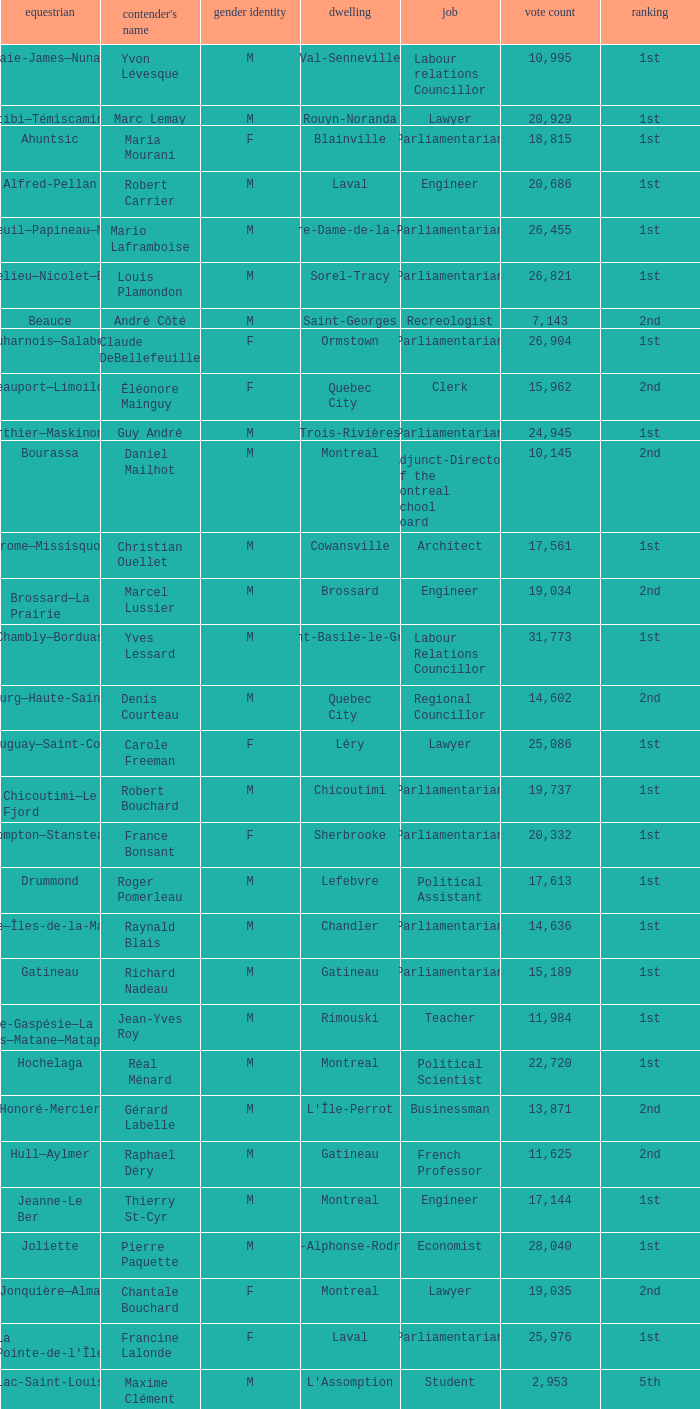Can you parse all the data within this table? {'header': ['equestrian', "contender's name", 'gender identity', 'dwelling', 'job', 'vote count', 'ranking'], 'rows': [['Abitibi—Baie-James—Nunavik—Eeyou', 'Yvon Lévesque', 'M', 'Val-Senneville', 'Labour relations Councillor', '10,995', '1st'], ['Abitibi—Témiscamingue', 'Marc Lemay', 'M', 'Rouyn-Noranda', 'Lawyer', '20,929', '1st'], ['Ahuntsic', 'Maria Mourani', 'F', 'Blainville', 'Parliamentarian', '18,815', '1st'], ['Alfred-Pellan', 'Robert Carrier', 'M', 'Laval', 'Engineer', '20,686', '1st'], ['Argenteuil—Papineau—Mirabel', 'Mario Laframboise', 'M', 'Notre-Dame-de-la-Paix', 'Parliamentarian', '26,455', '1st'], ['Bas-Richelieu—Nicolet—Bécancour', 'Louis Plamondon', 'M', 'Sorel-Tracy', 'Parliamentarian', '26,821', '1st'], ['Beauce', 'André Côté', 'M', 'Saint-Georges', 'Recreologist', '7,143', '2nd'], ['Beauharnois—Salaberry', 'Claude DeBellefeuille', 'F', 'Ormstown', 'Parliamentarian', '26,904', '1st'], ['Beauport—Limoilou', 'Éléonore Mainguy', 'F', 'Quebec City', 'Clerk', '15,962', '2nd'], ['Berthier—Maskinongé', 'Guy André', 'M', 'Trois-Rivières', 'Parliamentarian', '24,945', '1st'], ['Bourassa', 'Daniel Mailhot', 'M', 'Montreal', 'Adjunct-Director of the Montreal School Board', '10,145', '2nd'], ['Brome—Missisquoi', 'Christian Ouellet', 'M', 'Cowansville', 'Architect', '17,561', '1st'], ['Brossard—La Prairie', 'Marcel Lussier', 'M', 'Brossard', 'Engineer', '19,034', '2nd'], ['Chambly—Borduas', 'Yves Lessard', 'M', 'Saint-Basile-le-Grand', 'Labour Relations Councillor', '31,773', '1st'], ['Charlesbourg—Haute-Saint-Charles', 'Denis Courteau', 'M', 'Quebec City', 'Regional Councillor', '14,602', '2nd'], ['Châteauguay—Saint-Constant', 'Carole Freeman', 'F', 'Léry', 'Lawyer', '25,086', '1st'], ['Chicoutimi—Le Fjord', 'Robert Bouchard', 'M', 'Chicoutimi', 'Parliamentarian', '19,737', '1st'], ['Compton—Stanstead', 'France Bonsant', 'F', 'Sherbrooke', 'Parliamentarian', '20,332', '1st'], ['Drummond', 'Roger Pomerleau', 'M', 'Lefebvre', 'Political Assistant', '17,613', '1st'], ['Gaspésie—Îles-de-la-Madeleine', 'Raynald Blais', 'M', 'Chandler', 'Parliamentarian', '14,636', '1st'], ['Gatineau', 'Richard Nadeau', 'M', 'Gatineau', 'Parliamentarian', '15,189', '1st'], ['Haute-Gaspésie—La Mitis—Matane—Matapédia', 'Jean-Yves Roy', 'M', 'Rimouski', 'Teacher', '11,984', '1st'], ['Hochelaga', 'Réal Ménard', 'M', 'Montreal', 'Political Scientist', '22,720', '1st'], ['Honoré-Mercier', 'Gérard Labelle', 'M', "L'Île-Perrot", 'Businessman', '13,871', '2nd'], ['Hull—Aylmer', 'Raphael Déry', 'M', 'Gatineau', 'French Professor', '11,625', '2nd'], ['Jeanne-Le Ber', 'Thierry St-Cyr', 'M', 'Montreal', 'Engineer', '17,144', '1st'], ['Joliette', 'Pierre Paquette', 'M', 'Saint-Alphonse-Rodriguez', 'Economist', '28,040', '1st'], ['Jonquière—Alma', 'Chantale Bouchard', 'F', 'Montreal', 'Lawyer', '19,035', '2nd'], ["La Pointe-de-l'Île", 'Francine Lalonde', 'F', 'Laval', 'Parliamentarian', '25,976', '1st'], ['Lac-Saint-Louis', 'Maxime Clément', 'M', "L'Assomption", 'Student', '2,953', '5th'], ['LaSalle—Émard', 'Frédéric Isaya', 'M', 'Montreal', 'Actor', '10,384', '2nd'], ['Laurentides—Labelle', 'Johanne Deschamps', 'F', 'Mont-Laurier', 'Parliamentarian', '24,956', '1st'], ['Laurier—Sainte-Marie', 'Gilles Duceppe', 'M', 'Montreal', 'Parliamentarian', '24,103', '1st'], ['Laval', 'Nicole Demers', 'F', 'Laval', 'Parliamentarian', '19,085', '1st'], ['Laval—Les Îles', 'Mohamedali Jetha', 'M', 'Laval', 'Machinist', '12,576', '2nd'], ['Lévis—Bellechasse', 'Guy Bergeron', 'M', 'Quebec City', 'Political Scientist', '13,747', '2nd'], ['Longueuil—Pierre-Boucher', 'Jean Dorion', 'M', 'Montreal', 'Sociologist', '23,118', '1st'], ['Lotbinière—Chutes-de-la-Chaudière', 'Antoine Sarrazin-Bourgoin', 'M', 'Saint-Antoine-de-Tilly', 'Student', '12,738', '2nd'], ['Louis-Hébert', 'Pascal-Pierre Paillé', 'M', 'Quebec City', 'Teacher', '20,992', '1st'], ['Louis-Saint-Laurent', 'France Gagné', 'F', 'Quebec City', 'Technician', '13,330', '2nd'], ['Manicouagan', 'Gérard Asselin', 'M', 'Baie-Comeau', 'Parliamentarian', '15,272', '1st'], ['Marc-Aurèle-Fortin', 'Serge Ménard', 'M', 'Saint-Lambert', 'Lawyer', '25,552', '1st'], ["Mégantic—L'Érable", 'Pierre Turcotte', 'M', 'Thetford Mines', 'Notary', '12,283', '2nd'], ['Montcalm', 'Roger Gaudet', 'M', 'Saint-Liguori', 'Parliamentarian', '33,519', '1st'], ["Montmagny—L'Islet—Kamouraska—Rivière-du-Loup", 'Paul Crête', 'M', 'La Pocatière', 'Parliamentarian', '20,494', '1st'], ['Montmorency—Charlevoix—Haute-Côte-Nord', 'Michel Guimond', 'M', 'Boischatel', 'Parliamentarian and Lawyer', '21,068', '1st'], ['Mount Royal', 'Maryse Lavallée', 'F', 'Montreal', 'Director of Québec Alcohol Corporation', '1,543', '5th'], ['Notre-Dame-de-Grâce—Lachine', 'Eric Taillefer', 'M', 'Terrebonne', 'Student', '6,962', '3rd'], ['Outremont', 'Marcela Valdivia', 'F', 'Montreal', 'Lawyer', '4,554', '3rd'], ['Papineau', 'Vivian Barbot', 'F', 'Montreal', 'Parliamentarian', '16,535', '2nd'], ['Pierrefonds—Dollard', 'Reny Gagnon', 'M', 'Laval', 'Insurance Salesman', '4,357', '4th'], ['Pontiac', 'Marius Tremblay', 'M', 'Plaisance', 'Composer/Researcher', '9,576', '3rd'], ['Portneuf—Jacques-Cartier', 'Richard Côté', 'M', 'Neuville', 'Polling Director', '14,401', '2nd'], ['Québec', 'Christiane Gagnon', 'F', 'Quebec City', 'Real Estate Agent', '21,064', '1st'], ['Repentigny', 'Nicolas Dufour', 'M', 'Repentigny', 'Student', '31,007', '1st'], ['Richmond—Arthabaska', 'André Bellavance', 'M', 'Victoriaville', 'Parliamentarian', '23,913', '1st'], ['Rimouski-Neigette—Témiscouata—Les Basques', 'Claude Guimond', 'M', 'Rimouski', 'Farmer', '17,652', '1st'], ['Rivière-des-Mille-Îles', 'Luc Desnoyers', 'M', 'Montreal', 'Retired', '23,216', '1st'], ['Rivière-du-Nord', 'Monique Guay', 'F', 'Prévost', 'Parliamentarian', '26,588', '1st'], ['Roberval—Lac-Saint-Jean', 'Claude Pilote', 'M', 'Roberval', 'Businessman', '14,619', '2nd'], ['Rosemont—La Petite-Patrie', 'Bernard Bigras', 'M', 'Montreal', 'Parliamentarian', '27,260', '1st'], ['Saint-Bruno—Saint-Hubert', 'Carole Lavallée', 'F', 'Longueuil', 'Communicator', '23,767', '1st'], ['Saint-Hyacinthe—Bagot', 'Ève-Mary Thaï Thi Lac', 'F', 'Saint-Hyacinthe', 'Parliamentarian', '22,719', '1st'], ['Saint-Jean', 'Claude Bachand', 'M', 'Saint-Jean-sur-Richelieu', 'Parliamentarian', '26,506', '1st'], ['Saint-Lambert', 'Josée Beaudin', 'F', 'Belœil', 'Coordinator', '16,346', '1st'], ['Saint-Laurent—Cartierville', 'Jacques Lachaine', 'M', 'Montreal', 'Retired Teacher', '4,611', '3rd'], ['Saint-Léonard—Saint-Michel', 'Farid Salem', 'M', 'Longueuil', 'Consultant', '5,146', '3rd'], ['Saint-Maurice—Champlain', 'Jean-Yves Laforest', 'M', 'Shawinigan', 'Gym Teacher', '20,397', '1st'], ['Shefford', 'Robert Vincent', 'M', 'Granby', 'Parliamentarian', '21,650', '1st'], ['Sherbrooke', 'Serge Cardin', 'M', 'Sherbrooke', 'Parliamentarian', '25,502', '1st'], ['Terrebonne—Blainville', 'Diane Bourgeois', 'F', 'Terrebonne', 'Parliamentarian', '28,303', '1st'], ['Trois-Rivières', 'Paule Brunelle', 'F', 'Champlain', 'Parliamentarian', '22,405', '1st'], ['Vaudreuil—Soulanges', 'Meili Faille', 'F', 'Rigaud', 'Parliamentarian', '27,044', '1st'], ['Verchères—Les Patriotes', 'Luc Malo', 'M', 'Contrecoeur', 'Parliamentarian', '27,602', '1st'], ['Westmount—Ville-Marie', 'Charles Larivée', 'M', 'Montreal', 'Logistic Service Coordinator', '2,818', '4th']]} What gender is Luc Desnoyers? M. 